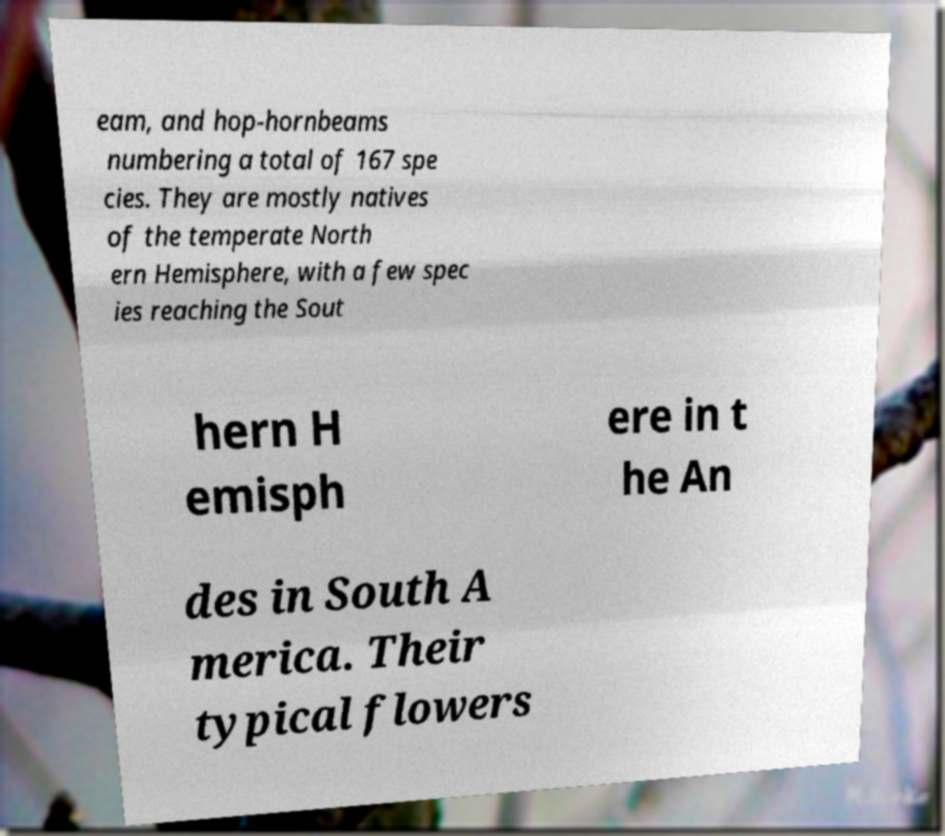Could you assist in decoding the text presented in this image and type it out clearly? eam, and hop-hornbeams numbering a total of 167 spe cies. They are mostly natives of the temperate North ern Hemisphere, with a few spec ies reaching the Sout hern H emisph ere in t he An des in South A merica. Their typical flowers 